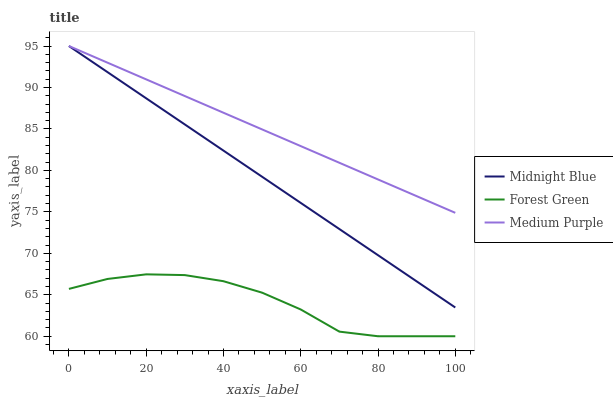Does Forest Green have the minimum area under the curve?
Answer yes or no. Yes. Does Medium Purple have the maximum area under the curve?
Answer yes or no. Yes. Does Midnight Blue have the minimum area under the curve?
Answer yes or no. No. Does Midnight Blue have the maximum area under the curve?
Answer yes or no. No. Is Midnight Blue the smoothest?
Answer yes or no. Yes. Is Forest Green the roughest?
Answer yes or no. Yes. Is Forest Green the smoothest?
Answer yes or no. No. Is Midnight Blue the roughest?
Answer yes or no. No. Does Midnight Blue have the lowest value?
Answer yes or no. No. Does Forest Green have the highest value?
Answer yes or no. No. Is Forest Green less than Medium Purple?
Answer yes or no. Yes. Is Medium Purple greater than Forest Green?
Answer yes or no. Yes. Does Forest Green intersect Medium Purple?
Answer yes or no. No. 